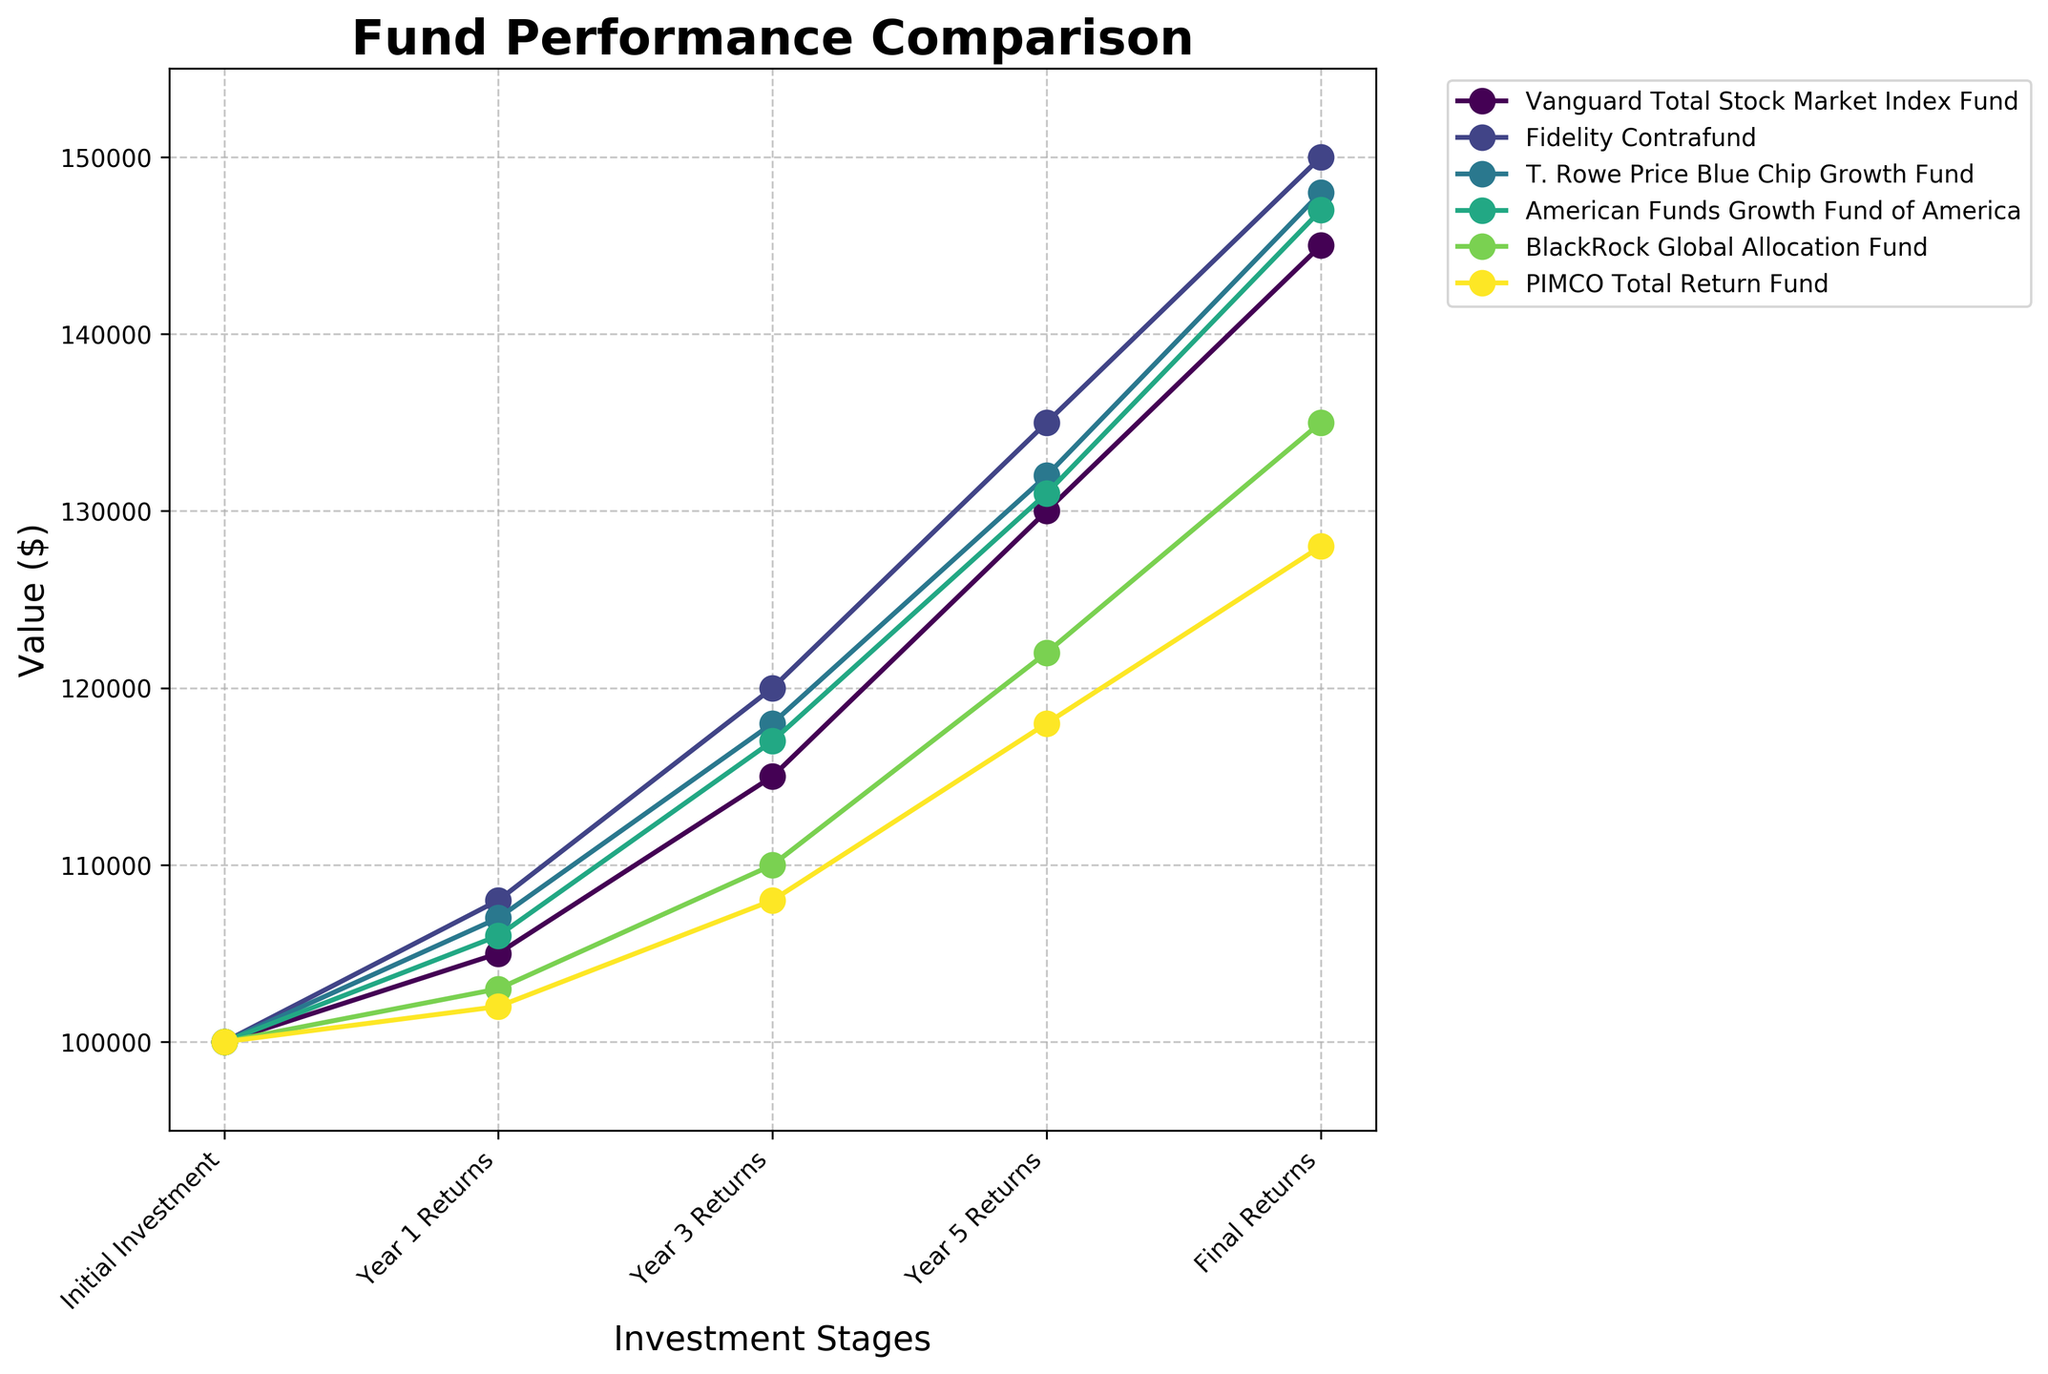What is the title of the figure? The title is usually placed at the top of the figure. It provides a summary of what the figure is about.
Answer: Fund Performance Comparison How many investment stages are shown on the x-axis? The x-axis represents the investment stages and shows the progression over time.
Answer: 5 What is the value of the Final Returns for the Vanguard Total Stock Market Index Fund? Identify the 'Vanguard Total Stock Market Index Fund' line and follow it to the 'Final Returns' point on the x-axis. The value on the y-axis at this point is the answer.
Answer: $145,000 Which fund has the highest Year 1 Returns? By comparing the height of the data points at 'Year 1 Returns' for all the lines, the fund with the highest point is the one with the highest returns.
Answer: Fidelity Contrafund What is the difference in Final Returns between the PIMCO Total Return Fund and the BlackRock Global Allocation Fund? Locate the 'Final Returns' values for both funds on the figure: PIMCO Total Return Fund is $128,000, and BlackRock Global Allocation Fund is $135,000. Then, subtract the smaller value from the larger one.
Answer: $7,000 Which fund shows the smallest growth from Initial Investment to Final Returns? Growth can be determined by subtracting the 'Initial Investment' value from the 'Final Returns' value for each fund. The fund with the smallest difference shows the smallest growth.
Answer: PIMCO Total Return Fund What is the approximate average value of Final Returns for all the funds? Sum up the 'Final Returns' values for all funds and then divide by the number of funds: (145000 + 150000 + 148000 + 147000 + 135000 + 128000) / 6.
Answer: $142,167 Between Year 3 Returns and Final Returns, which fund shows the greatest increase? Calculate the difference between 'Year 3 Returns' and 'Final Returns' for each fund. The greatest difference indicates the greatest increase.
Answer: Fidelity Contrafund At Year 5 Returns, which two funds have the closest values? Find 'Year 5 Returns' values for all funds and identify which two are the closest by calculating pairwise differences and finding the minimum.
Answer: T. Rowe Price Blue Chip Growth Fund and American Funds Growth Fund of America 